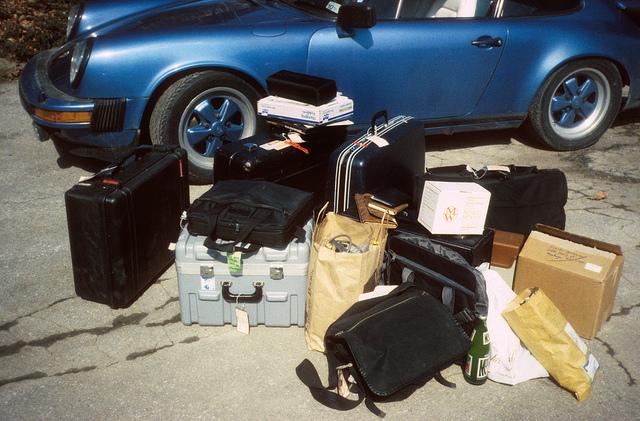How many suitcases are there?
Give a very brief answer. 4. Is this luggage about to go for a ride on an airplane?
Concise answer only. No. What is next to the car?
Give a very brief answer. Luggage. Is one of the luggage red?
Be succinct. No. What color is the sports car?
Short answer required. Blue. How many brown bags are there?
Give a very brief answer. 1. 